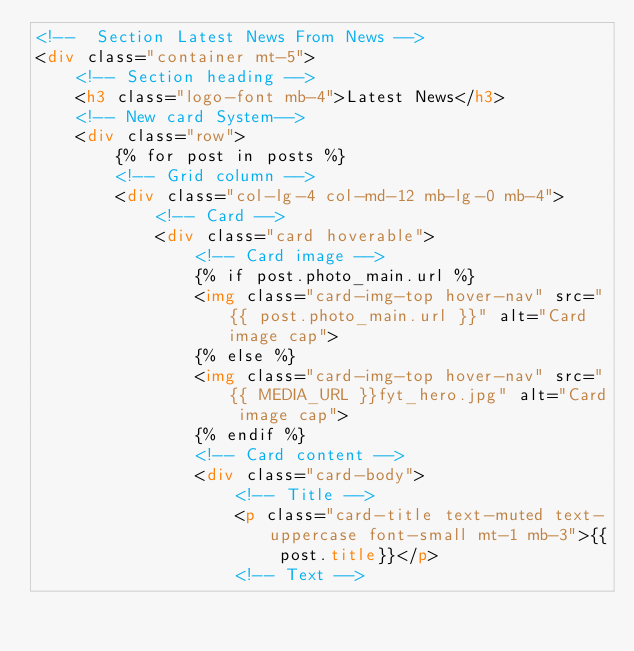<code> <loc_0><loc_0><loc_500><loc_500><_HTML_><!--  Section Latest News From News -->
<div class="container mt-5">
    <!-- Section heading -->
    <h3 class="logo-font mb-4">Latest News</h3>
    <!-- New card System-->
    <div class="row">
        {% for post in posts %}
        <!-- Grid column -->
        <div class="col-lg-4 col-md-12 mb-lg-0 mb-4">
            <!-- Card -->
            <div class="card hoverable">
                <!-- Card image -->
                {% if post.photo_main.url %}
                <img class="card-img-top hover-nav" src="{{ post.photo_main.url }}" alt="Card image cap">
                {% else %}
                <img class="card-img-top hover-nav" src="{{ MEDIA_URL }}fyt_hero.jpg" alt="Card image cap">
                {% endif %}
                <!-- Card content -->
                <div class="card-body">
                    <!-- Title -->
                    <p class="card-title text-muted text-uppercase font-small mt-1 mb-3">{{ post.title}}</p>
                    <!-- Text --></code> 